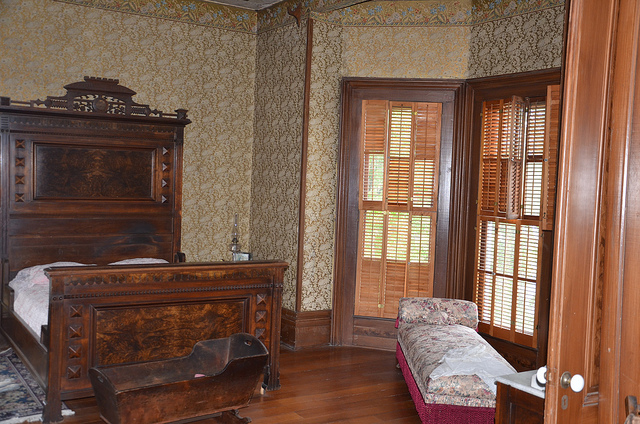<image>What object is on the floor, at the foot of the bed? I don't know exactily what object is on the floor, at the foot of the bed. It can be bassinet, cradle, shoes or crib. What object is on the floor, at the foot of the bed? I am not sure what object is on the floor, at the foot of the bed. It can be seen 'bassinet', 'cradle', 'shoes', 'baby cradle', or 'crib'. 